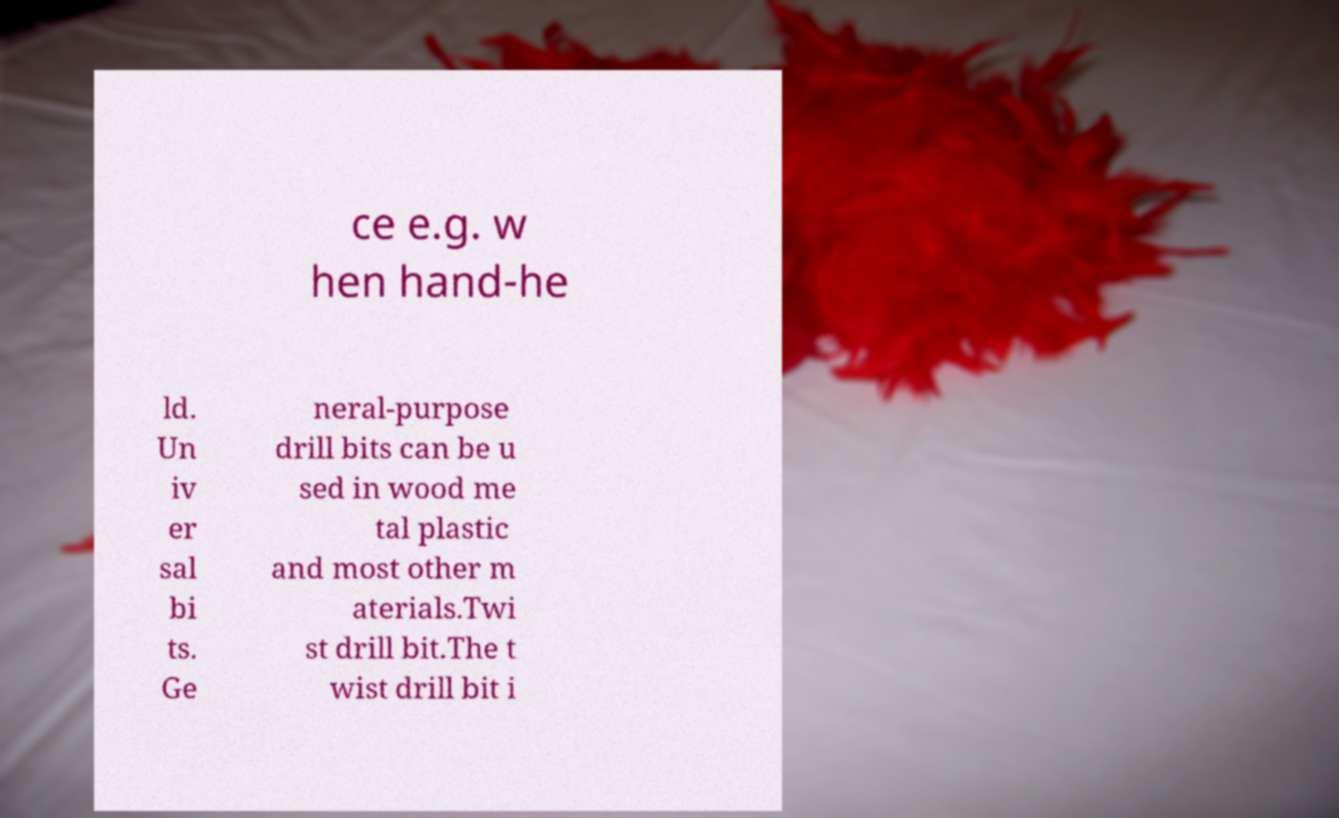What messages or text are displayed in this image? I need them in a readable, typed format. ce e.g. w hen hand-he ld. Un iv er sal bi ts. Ge neral-purpose drill bits can be u sed in wood me tal plastic and most other m aterials.Twi st drill bit.The t wist drill bit i 